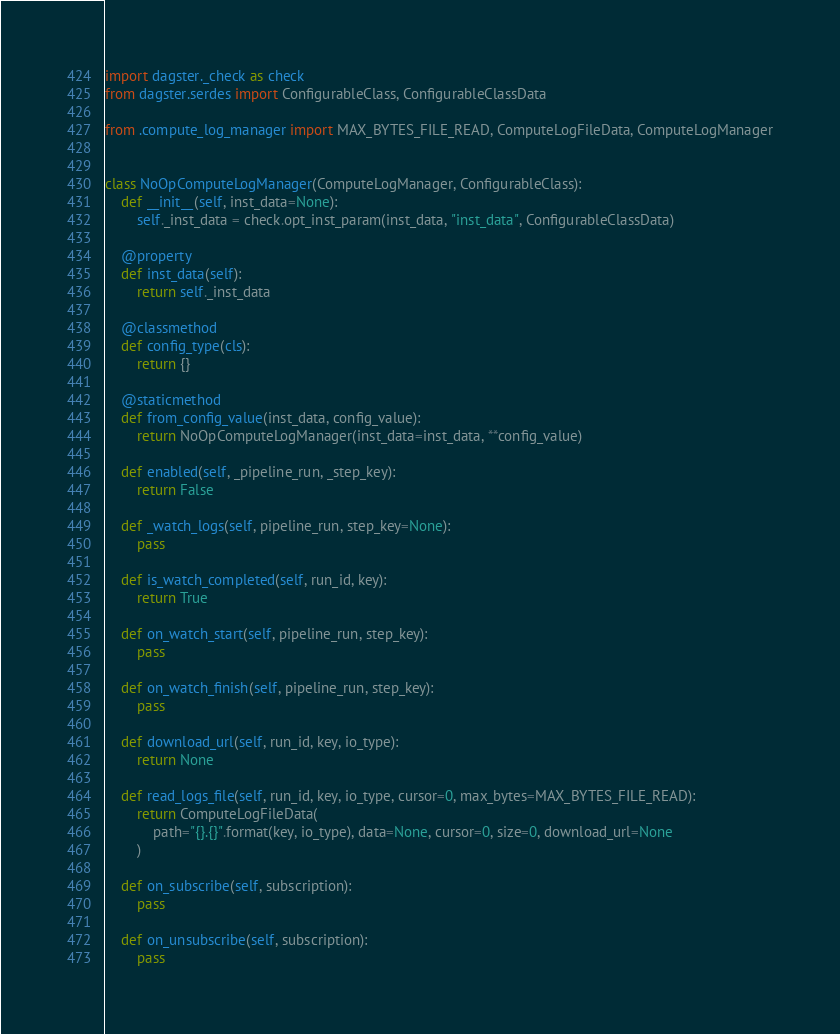<code> <loc_0><loc_0><loc_500><loc_500><_Python_>import dagster._check as check
from dagster.serdes import ConfigurableClass, ConfigurableClassData

from .compute_log_manager import MAX_BYTES_FILE_READ, ComputeLogFileData, ComputeLogManager


class NoOpComputeLogManager(ComputeLogManager, ConfigurableClass):
    def __init__(self, inst_data=None):
        self._inst_data = check.opt_inst_param(inst_data, "inst_data", ConfigurableClassData)

    @property
    def inst_data(self):
        return self._inst_data

    @classmethod
    def config_type(cls):
        return {}

    @staticmethod
    def from_config_value(inst_data, config_value):
        return NoOpComputeLogManager(inst_data=inst_data, **config_value)

    def enabled(self, _pipeline_run, _step_key):
        return False

    def _watch_logs(self, pipeline_run, step_key=None):
        pass

    def is_watch_completed(self, run_id, key):
        return True

    def on_watch_start(self, pipeline_run, step_key):
        pass

    def on_watch_finish(self, pipeline_run, step_key):
        pass

    def download_url(self, run_id, key, io_type):
        return None

    def read_logs_file(self, run_id, key, io_type, cursor=0, max_bytes=MAX_BYTES_FILE_READ):
        return ComputeLogFileData(
            path="{}.{}".format(key, io_type), data=None, cursor=0, size=0, download_url=None
        )

    def on_subscribe(self, subscription):
        pass

    def on_unsubscribe(self, subscription):
        pass
</code> 